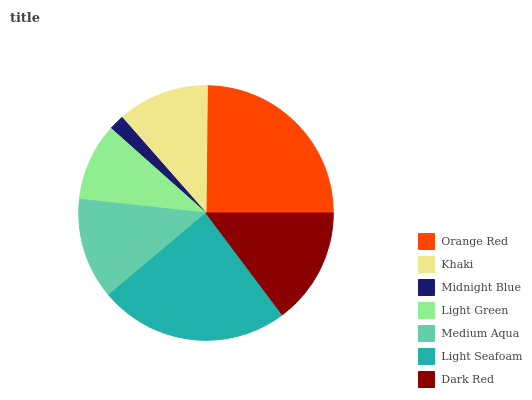Is Midnight Blue the minimum?
Answer yes or no. Yes. Is Orange Red the maximum?
Answer yes or no. Yes. Is Khaki the minimum?
Answer yes or no. No. Is Khaki the maximum?
Answer yes or no. No. Is Orange Red greater than Khaki?
Answer yes or no. Yes. Is Khaki less than Orange Red?
Answer yes or no. Yes. Is Khaki greater than Orange Red?
Answer yes or no. No. Is Orange Red less than Khaki?
Answer yes or no. No. Is Medium Aqua the high median?
Answer yes or no. Yes. Is Medium Aqua the low median?
Answer yes or no. Yes. Is Dark Red the high median?
Answer yes or no. No. Is Light Seafoam the low median?
Answer yes or no. No. 